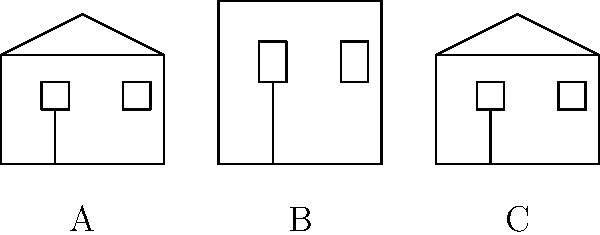Which of the simple house sketches (A, B, or C) best represents the Italianate architectural style commonly found in 19th-century Missouri buildings? To identify the Italianate style among these sketches, let's analyze each one:

1. Sketch A:
   - Features a gabled roof (triangular shape)
   - Symmetrical facade with centered door
   - Windows aligned horizontally
   - This represents the Greek Revival or Federal style

2. Sketch B:
   - Has a flat or low-pitched roof
   - Taller, more vertical proportion
   - Symmetrical facade with centered door
   - Windows aligned vertically
   - This represents the Italianate style

3. Sketch C:
   - Features a gabled roof (triangular shape)
   - Symmetrical facade with centered door
   - Windows aligned horizontally
   - This represents the Federal or Greek Revival style

The Italianate style, popular in Missouri during the mid-to-late 19th century, is characterized by:
- Low-pitched or flat roofs
- Tall, narrow windows
- Elaborate window crowns
- Wide, overhanging eaves with decorative brackets
- An overall vertical emphasis

Among the given sketches, B most closely matches these characteristics, particularly with its flat roof and taller, more vertical proportion.
Answer: B 